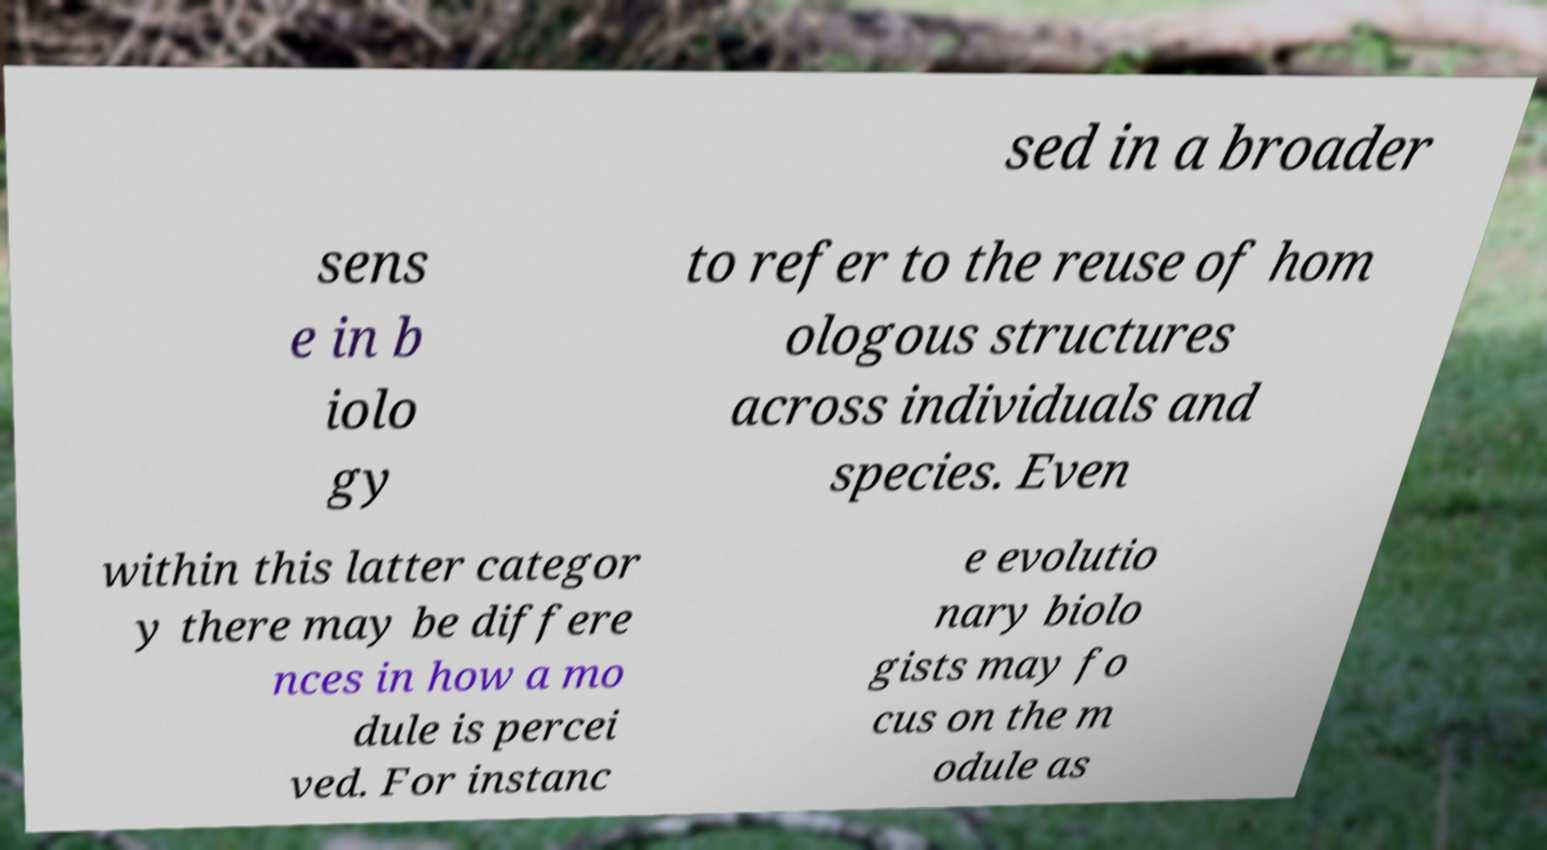What messages or text are displayed in this image? I need them in a readable, typed format. sed in a broader sens e in b iolo gy to refer to the reuse of hom ologous structures across individuals and species. Even within this latter categor y there may be differe nces in how a mo dule is percei ved. For instanc e evolutio nary biolo gists may fo cus on the m odule as 